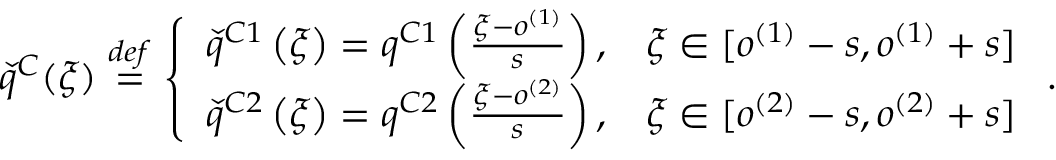<formula> <loc_0><loc_0><loc_500><loc_500>\check { q } ^ { C } ( \xi ) \overset { d e f } { = } \left \{ \begin{array} { l l } { \check { q } ^ { C 1 } \left ( \xi \right ) = q ^ { C 1 } \left ( \frac { \xi - o ^ { ( 1 ) } } { s } \right ) , } & { \xi \in [ o ^ { ( 1 ) } - s , o ^ { ( 1 ) } + s ] } \\ { \check { q } ^ { C 2 } \left ( \xi \right ) = q ^ { C 2 } \left ( \frac { \xi - o ^ { ( 2 ) } } { s } \right ) , } & { \xi \in [ o ^ { ( 2 ) } - s , o ^ { ( 2 ) } + s ] } \end{array} .</formula> 